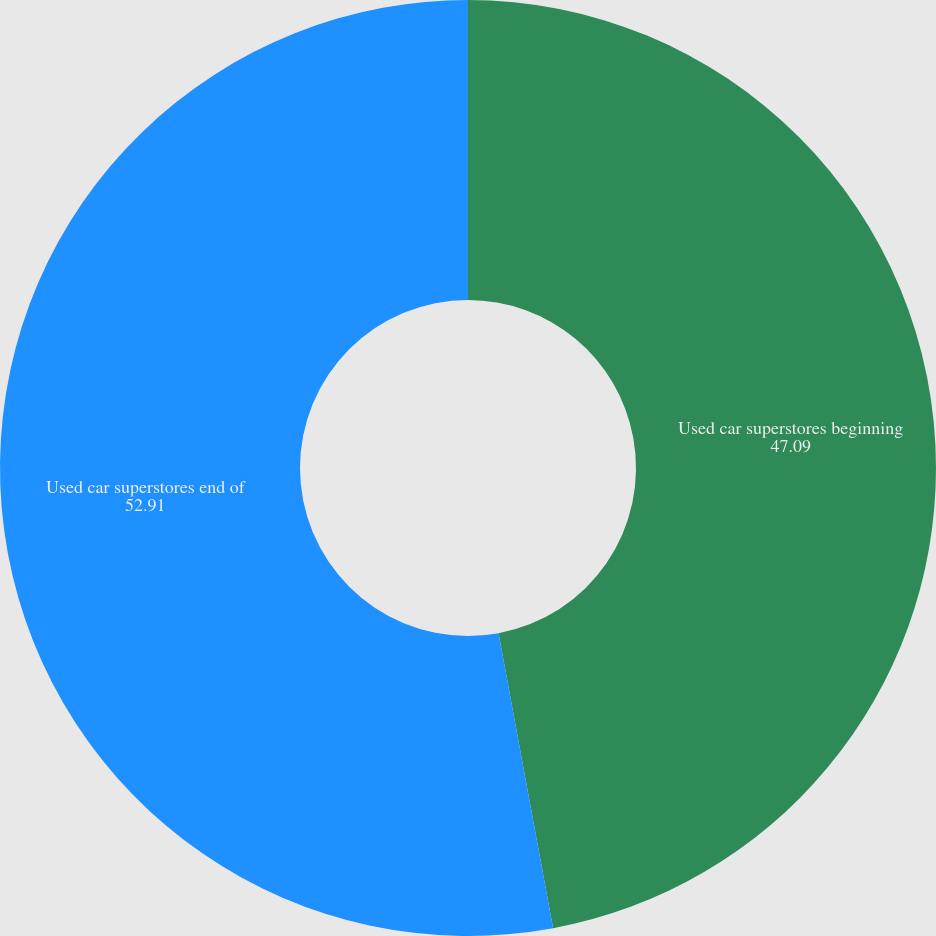<chart> <loc_0><loc_0><loc_500><loc_500><pie_chart><fcel>Used car superstores beginning<fcel>Used car superstores end of<nl><fcel>47.09%<fcel>52.91%<nl></chart> 